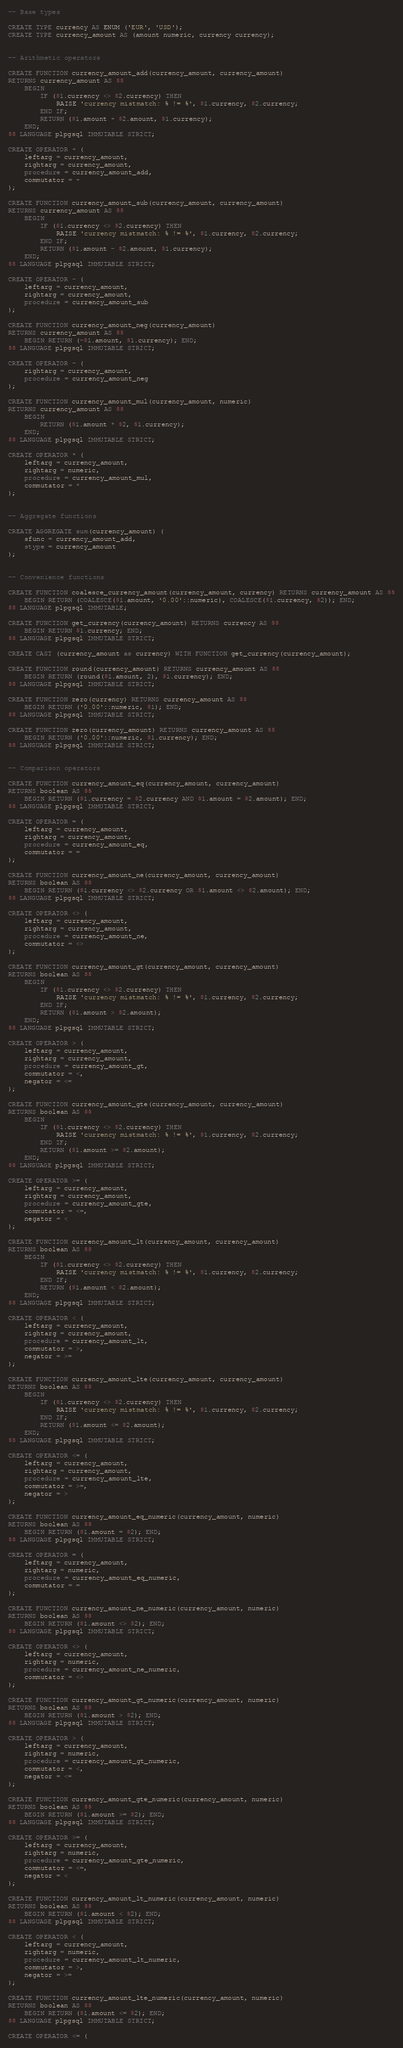<code> <loc_0><loc_0><loc_500><loc_500><_SQL_>-- Base types

CREATE TYPE currency AS ENUM ('EUR', 'USD');
CREATE TYPE currency_amount AS (amount numeric, currency currency);


-- Arithmetic operators

CREATE FUNCTION currency_amount_add(currency_amount, currency_amount)
RETURNS currency_amount AS $$
    BEGIN
        IF ($1.currency <> $2.currency) THEN
            RAISE 'currency mistmatch: % != %', $1.currency, $2.currency;
        END IF;
        RETURN ($1.amount + $2.amount, $1.currency);
    END;
$$ LANGUAGE plpgsql IMMUTABLE STRICT;

CREATE OPERATOR + (
    leftarg = currency_amount,
    rightarg = currency_amount,
    procedure = currency_amount_add,
    commutator = +
);

CREATE FUNCTION currency_amount_sub(currency_amount, currency_amount)
RETURNS currency_amount AS $$
    BEGIN
        IF ($1.currency <> $2.currency) THEN
            RAISE 'currency mistmatch: % != %', $1.currency, $2.currency;
        END IF;
        RETURN ($1.amount - $2.amount, $1.currency);
    END;
$$ LANGUAGE plpgsql IMMUTABLE STRICT;

CREATE OPERATOR - (
    leftarg = currency_amount,
    rightarg = currency_amount,
    procedure = currency_amount_sub
);

CREATE FUNCTION currency_amount_neg(currency_amount)
RETURNS currency_amount AS $$
    BEGIN RETURN (-$1.amount, $1.currency); END;
$$ LANGUAGE plpgsql IMMUTABLE STRICT;

CREATE OPERATOR - (
    rightarg = currency_amount,
    procedure = currency_amount_neg
);

CREATE FUNCTION currency_amount_mul(currency_amount, numeric)
RETURNS currency_amount AS $$
    BEGIN
        RETURN ($1.amount * $2, $1.currency);
    END;
$$ LANGUAGE plpgsql IMMUTABLE STRICT;

CREATE OPERATOR * (
    leftarg = currency_amount,
    rightarg = numeric,
    procedure = currency_amount_mul,
    commutator = *
);


-- Aggregate functions

CREATE AGGREGATE sum(currency_amount) (
    sfunc = currency_amount_add,
    stype = currency_amount
);


-- Convenience functions

CREATE FUNCTION coalesce_currency_amount(currency_amount, currency) RETURNS currency_amount AS $$
    BEGIN RETURN (COALESCE($1.amount, '0.00'::numeric), COALESCE($1.currency, $2)); END;
$$ LANGUAGE plpgsql IMMUTABLE;

CREATE FUNCTION get_currency(currency_amount) RETURNS currency AS $$
    BEGIN RETURN $1.currency; END;
$$ LANGUAGE plpgsql IMMUTABLE STRICT;

CREATE CAST (currency_amount as currency) WITH FUNCTION get_currency(currency_amount);

CREATE FUNCTION round(currency_amount) RETURNS currency_amount AS $$
    BEGIN RETURN (round($1.amount, 2), $1.currency); END;
$$ LANGUAGE plpgsql IMMUTABLE STRICT;

CREATE FUNCTION zero(currency) RETURNS currency_amount AS $$
    BEGIN RETURN ('0.00'::numeric, $1); END;
$$ LANGUAGE plpgsql IMMUTABLE STRICT;

CREATE FUNCTION zero(currency_amount) RETURNS currency_amount AS $$
    BEGIN RETURN ('0.00'::numeric, $1.currency); END;
$$ LANGUAGE plpgsql IMMUTABLE STRICT;


-- Comparison operators

CREATE FUNCTION currency_amount_eq(currency_amount, currency_amount)
RETURNS boolean AS $$
    BEGIN RETURN ($1.currency = $2.currency AND $1.amount = $2.amount); END;
$$ LANGUAGE plpgsql IMMUTABLE STRICT;

CREATE OPERATOR = (
    leftarg = currency_amount,
    rightarg = currency_amount,
    procedure = currency_amount_eq,
    commutator = =
);

CREATE FUNCTION currency_amount_ne(currency_amount, currency_amount)
RETURNS boolean AS $$
    BEGIN RETURN ($1.currency <> $2.currency OR $1.amount <> $2.amount); END;
$$ LANGUAGE plpgsql IMMUTABLE STRICT;

CREATE OPERATOR <> (
    leftarg = currency_amount,
    rightarg = currency_amount,
    procedure = currency_amount_ne,
    commutator = <>
);

CREATE FUNCTION currency_amount_gt(currency_amount, currency_amount)
RETURNS boolean AS $$
    BEGIN
        IF ($1.currency <> $2.currency) THEN
            RAISE 'currency mistmatch: % != %', $1.currency, $2.currency;
        END IF;
        RETURN ($1.amount > $2.amount);
    END;
$$ LANGUAGE plpgsql IMMUTABLE STRICT;

CREATE OPERATOR > (
    leftarg = currency_amount,
    rightarg = currency_amount,
    procedure = currency_amount_gt,
    commutator = <,
    negator = <=
);

CREATE FUNCTION currency_amount_gte(currency_amount, currency_amount)
RETURNS boolean AS $$
    BEGIN
        IF ($1.currency <> $2.currency) THEN
            RAISE 'currency mistmatch: % != %', $1.currency, $2.currency;
        END IF;
        RETURN ($1.amount >= $2.amount);
    END;
$$ LANGUAGE plpgsql IMMUTABLE STRICT;

CREATE OPERATOR >= (
    leftarg = currency_amount,
    rightarg = currency_amount,
    procedure = currency_amount_gte,
    commutator = <=,
    negator = <
);

CREATE FUNCTION currency_amount_lt(currency_amount, currency_amount)
RETURNS boolean AS $$
    BEGIN
        IF ($1.currency <> $2.currency) THEN
            RAISE 'currency mistmatch: % != %', $1.currency, $2.currency;
        END IF;
        RETURN ($1.amount < $2.amount);
    END;
$$ LANGUAGE plpgsql IMMUTABLE STRICT;

CREATE OPERATOR < (
    leftarg = currency_amount,
    rightarg = currency_amount,
    procedure = currency_amount_lt,
    commutator = >,
    negator = >=
);

CREATE FUNCTION currency_amount_lte(currency_amount, currency_amount)
RETURNS boolean AS $$
    BEGIN
        IF ($1.currency <> $2.currency) THEN
            RAISE 'currency mistmatch: % != %', $1.currency, $2.currency;
        END IF;
        RETURN ($1.amount <= $2.amount);
    END;
$$ LANGUAGE plpgsql IMMUTABLE STRICT;

CREATE OPERATOR <= (
    leftarg = currency_amount,
    rightarg = currency_amount,
    procedure = currency_amount_lte,
    commutator = >=,
    negator = >
);

CREATE FUNCTION currency_amount_eq_numeric(currency_amount, numeric)
RETURNS boolean AS $$
    BEGIN RETURN ($1.amount = $2); END;
$$ LANGUAGE plpgsql IMMUTABLE STRICT;

CREATE OPERATOR = (
    leftarg = currency_amount,
    rightarg = numeric,
    procedure = currency_amount_eq_numeric,
    commutator = =
);

CREATE FUNCTION currency_amount_ne_numeric(currency_amount, numeric)
RETURNS boolean AS $$
    BEGIN RETURN ($1.amount <> $2); END;
$$ LANGUAGE plpgsql IMMUTABLE STRICT;

CREATE OPERATOR <> (
    leftarg = currency_amount,
    rightarg = numeric,
    procedure = currency_amount_ne_numeric,
    commutator = <>
);

CREATE FUNCTION currency_amount_gt_numeric(currency_amount, numeric)
RETURNS boolean AS $$
    BEGIN RETURN ($1.amount > $2); END;
$$ LANGUAGE plpgsql IMMUTABLE STRICT;

CREATE OPERATOR > (
    leftarg = currency_amount,
    rightarg = numeric,
    procedure = currency_amount_gt_numeric,
    commutator = <,
    negator = <=
);

CREATE FUNCTION currency_amount_gte_numeric(currency_amount, numeric)
RETURNS boolean AS $$
    BEGIN RETURN ($1.amount >= $2); END;
$$ LANGUAGE plpgsql IMMUTABLE STRICT;

CREATE OPERATOR >= (
    leftarg = currency_amount,
    rightarg = numeric,
    procedure = currency_amount_gte_numeric,
    commutator = <=,
    negator = <
);

CREATE FUNCTION currency_amount_lt_numeric(currency_amount, numeric)
RETURNS boolean AS $$
    BEGIN RETURN ($1.amount < $2); END;
$$ LANGUAGE plpgsql IMMUTABLE STRICT;

CREATE OPERATOR < (
    leftarg = currency_amount,
    rightarg = numeric,
    procedure = currency_amount_lt_numeric,
    commutator = >,
    negator = >=
);

CREATE FUNCTION currency_amount_lte_numeric(currency_amount, numeric)
RETURNS boolean AS $$
    BEGIN RETURN ($1.amount <= $2); END;
$$ LANGUAGE plpgsql IMMUTABLE STRICT;

CREATE OPERATOR <= (</code> 